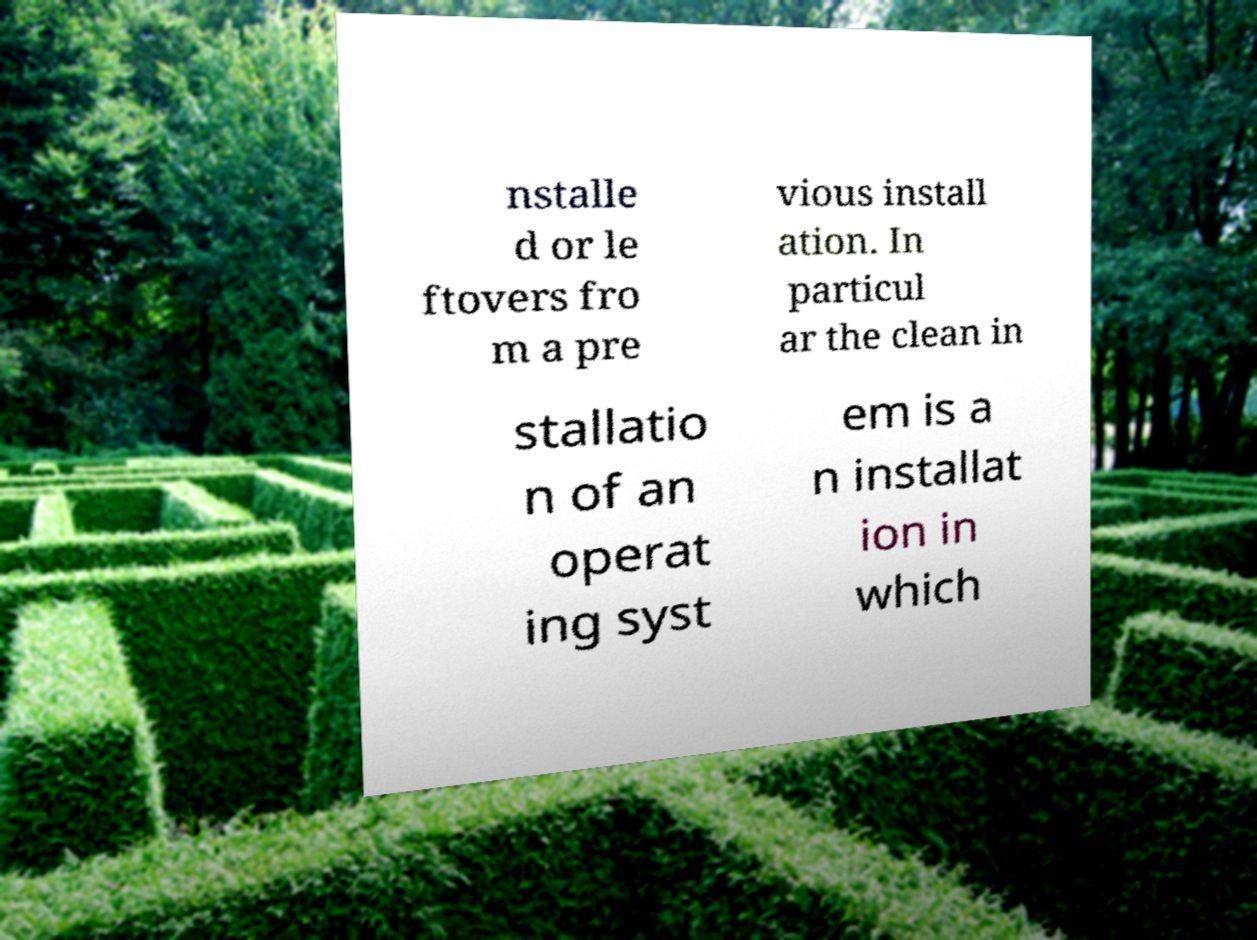For documentation purposes, I need the text within this image transcribed. Could you provide that? nstalle d or le ftovers fro m a pre vious install ation. In particul ar the clean in stallatio n of an operat ing syst em is a n installat ion in which 